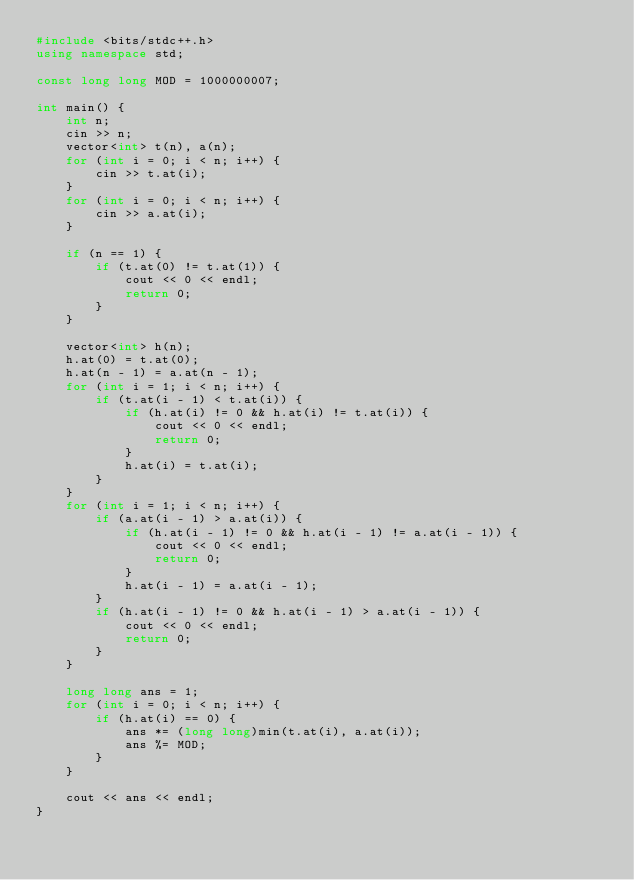Convert code to text. <code><loc_0><loc_0><loc_500><loc_500><_C++_>#include <bits/stdc++.h>
using namespace std;

const long long MOD = 1000000007;

int main() {
    int n;
    cin >> n;
    vector<int> t(n), a(n);
    for (int i = 0; i < n; i++) {
        cin >> t.at(i);
    }
    for (int i = 0; i < n; i++) {
        cin >> a.at(i);
    }

    if (n == 1) {
        if (t.at(0) != t.at(1)) {
            cout << 0 << endl;
            return 0;
        }
    }

    vector<int> h(n);
    h.at(0) = t.at(0);
    h.at(n - 1) = a.at(n - 1);
    for (int i = 1; i < n; i++) {
        if (t.at(i - 1) < t.at(i)) {
            if (h.at(i) != 0 && h.at(i) != t.at(i)) {
                cout << 0 << endl;
                return 0;
            }
            h.at(i) = t.at(i); 
        }
    }
    for (int i = 1; i < n; i++) {
        if (a.at(i - 1) > a.at(i)) {
            if (h.at(i - 1) != 0 && h.at(i - 1) != a.at(i - 1)) {
                cout << 0 << endl;
                return 0;
            }
            h.at(i - 1) = a.at(i - 1);
        }
        if (h.at(i - 1) != 0 && h.at(i - 1) > a.at(i - 1)) {
            cout << 0 << endl;
            return 0;
        } 
    }
    
    long long ans = 1;
    for (int i = 0; i < n; i++) {
        if (h.at(i) == 0) {
            ans *= (long long)min(t.at(i), a.at(i));
            ans %= MOD;
        }
    }

    cout << ans << endl;
}</code> 